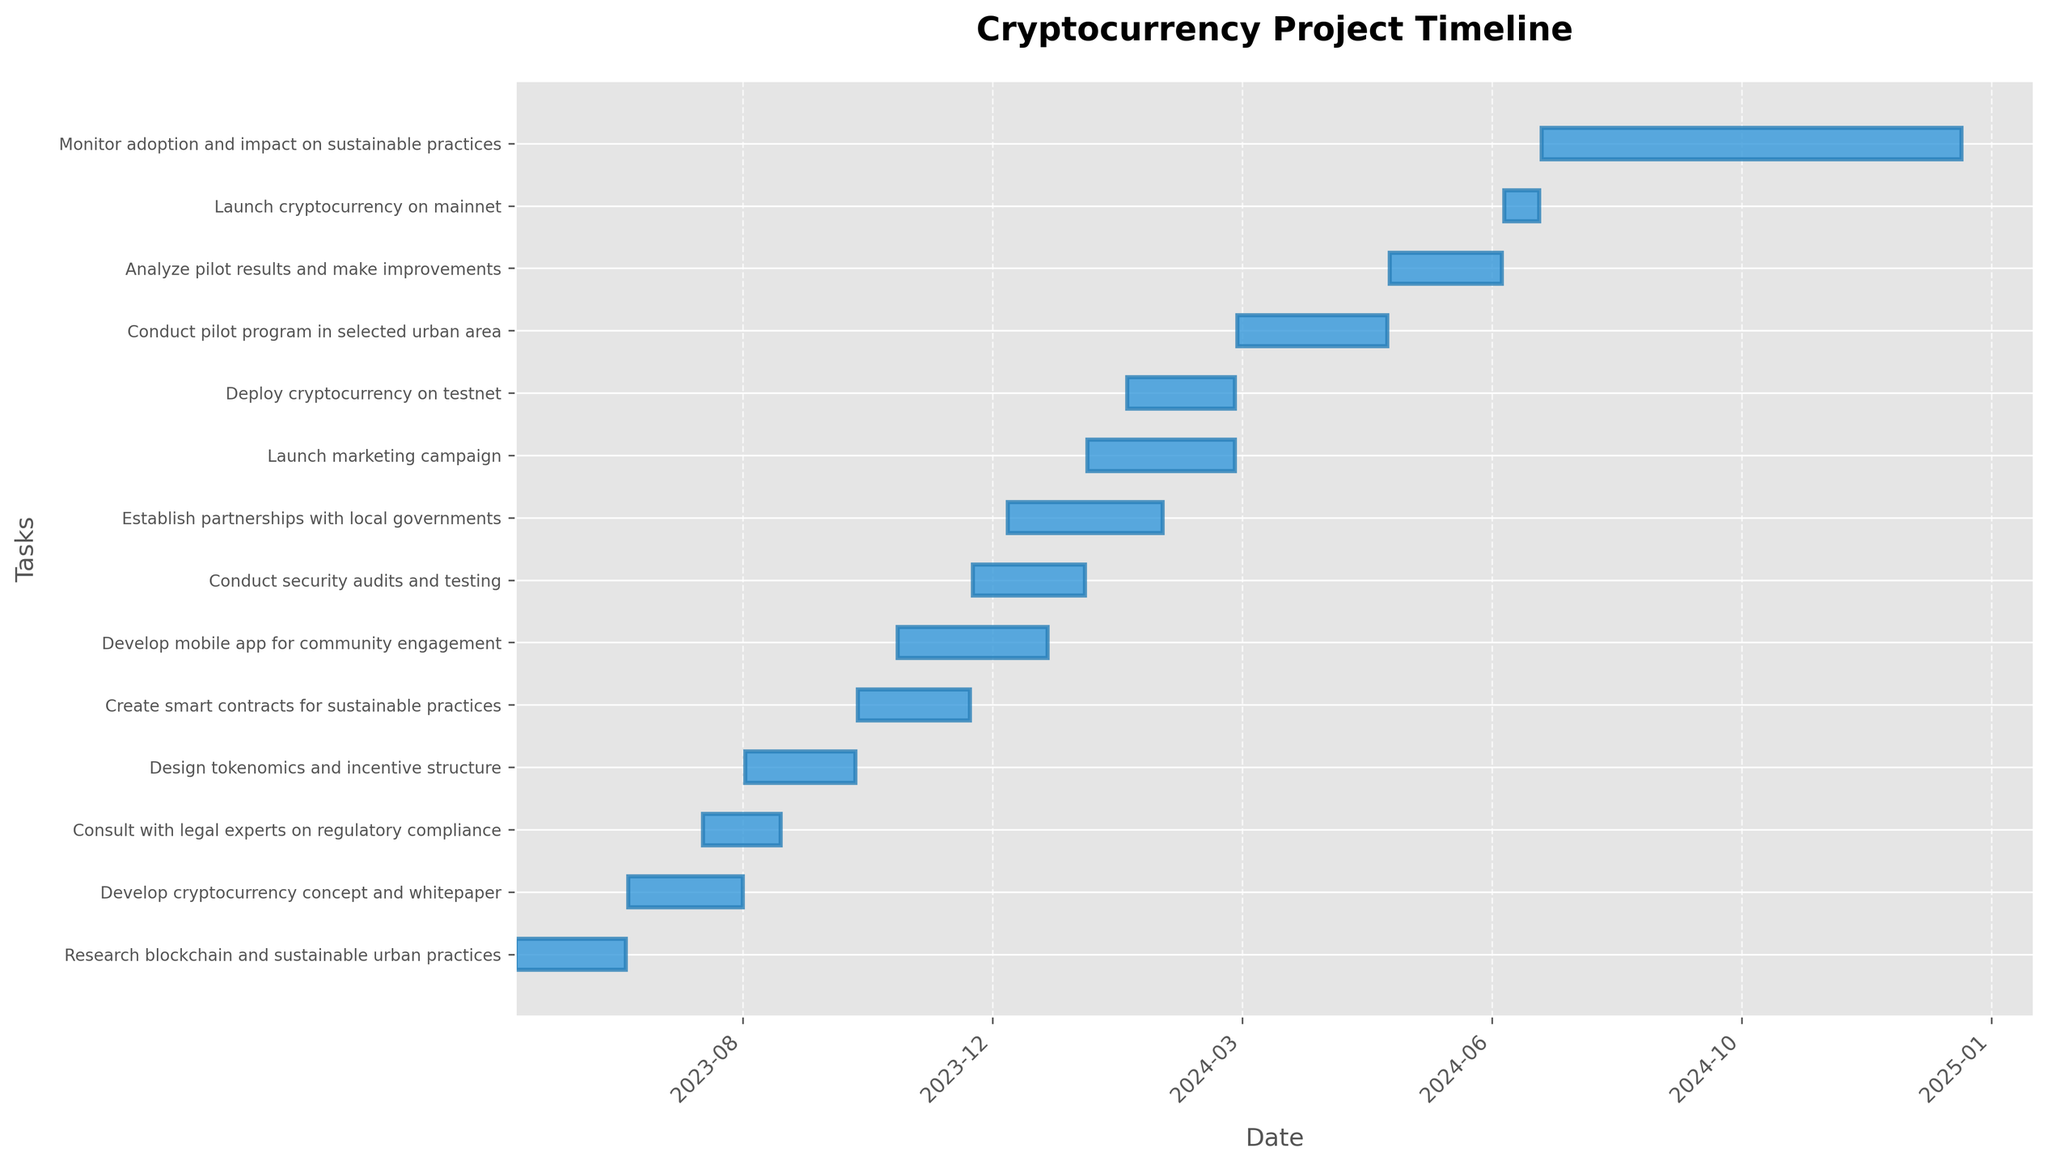What's the title of the Gantt Chart? The title is usually placed at the top center of the chart, providing a quick summary of what the chart represents. Here, it says "Cryptocurrency Project Timeline"
Answer: Cryptocurrency Project Timeline What is the duration of the longest task represented in the chart? The duration of each task is given. The task with the longest duration is "Monitor adoption and impact on sustainable practices," lasting from 2024-07-16 to 2024-12-31. Calculating the days, the duration is 169 days
Answer: 169 days How many tasks are scheduled to start in the month of December 2023? Look at the x-axis formatted for dates and check the tasks starting in December 2023. Two tasks start in December: "Conduct security audits and testing" on December 1st and "Establish partnerships with local governments" on December 15th
Answer: 2 tasks Which task starts immediately after "Develop cryptocurrency concept and whitepaper" ends? "Develop cryptocurrency concept and whitepaper" ends on 2023-08-31. The next task starting after this is "Consult with legal experts on regulatory compliance," starting on 2023-08-15, which overlaps. But to avoid overlapping, "Design tokenomics and incentive structure" starts on 2023-09-01
Answer: Design tokenomics and incentive structure What task finishes closest to the end date of "Develop mobile app for community engagement"? "Develop mobile app for community engagement" ends on 2023-12-31. The closest task ending date around this time is "Conduct security audits and testing," ending on 2024-01-15
Answer: Conduct security audits and testing Does any task overlap with "Launch marketing campaign"? If yes, which is it? "Launch marketing campaign" runs from 2024-01-16 to 2024-03-15. Overlap checking, "Establish partnerships with local governments" (2023-12-15 to 2024-02-15) and "Deploy cryptocurrency on testnet" (2024-02-01 to 2024-03-15) overlap with it. These tasks' periods intersect with the campaign dates
Answer: Yes, "Establish partnerships with local governments" and "Deploy cryptocurrency on testnet" Which task has the shortest duration? Reviewing all tasks' duration, "Launch cryptocurrency on mainnet" is the shortest, lasting from 2024-07-01 to 2024-07-15, which is 15 days
Answer: Launch cryptocurrency on mainnet How many tasks are planned to start in the year 2023? By observing the start dates in the chart, tasks planned to start in the year 2023 are: "Research blockchain and sustainable urban practices," "Develop cryptocurrency concept and whitepaper," "Consult with legal experts on regulatory compliance," "Design tokenomics and incentive structure," "Create smart contracts for sustainable practices," "Develop mobile app for community engagement," "Conduct security audits and testing," "Establish partnerships with local governments"
Answer: 8 tasks Which tasks are planned to be completed before the end of 2023? Tasks ending by December 31, 2023, include: "Research blockchain and sustainable urban practices," "Develop cryptocurrency concept and whitepaper," "Consult with legal experts on regulatory compliance," "Design tokenomics and incentive structure," "Create smart contracts for sustainable practices," and "Develop mobile app for community engagement"
Answer: 6 tasks 